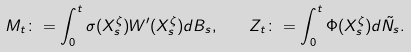Convert formula to latex. <formula><loc_0><loc_0><loc_500><loc_500>M _ { t } \colon = \int _ { 0 } ^ { t } \sigma ( X _ { s } ^ { \zeta } ) W ^ { \prime } ( X _ { s } ^ { \zeta } ) d B _ { s } , \quad Z _ { t } \colon = \int _ { 0 } ^ { t } \Phi ( X _ { s } ^ { \zeta } ) d \tilde { N } _ { s } .</formula> 